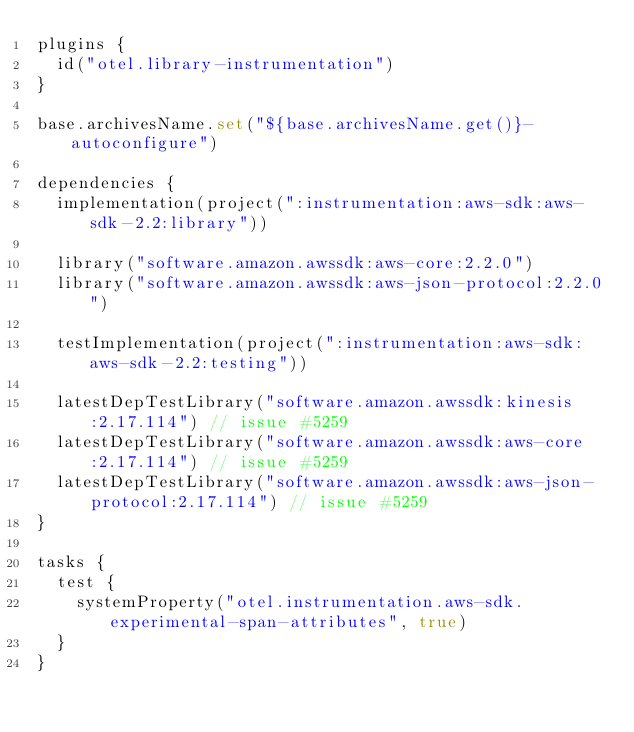Convert code to text. <code><loc_0><loc_0><loc_500><loc_500><_Kotlin_>plugins {
  id("otel.library-instrumentation")
}

base.archivesName.set("${base.archivesName.get()}-autoconfigure")

dependencies {
  implementation(project(":instrumentation:aws-sdk:aws-sdk-2.2:library"))

  library("software.amazon.awssdk:aws-core:2.2.0")
  library("software.amazon.awssdk:aws-json-protocol:2.2.0")

  testImplementation(project(":instrumentation:aws-sdk:aws-sdk-2.2:testing"))

  latestDepTestLibrary("software.amazon.awssdk:kinesis:2.17.114") // issue #5259
  latestDepTestLibrary("software.amazon.awssdk:aws-core:2.17.114") // issue #5259
  latestDepTestLibrary("software.amazon.awssdk:aws-json-protocol:2.17.114") // issue #5259
}

tasks {
  test {
    systemProperty("otel.instrumentation.aws-sdk.experimental-span-attributes", true)
  }
}
</code> 